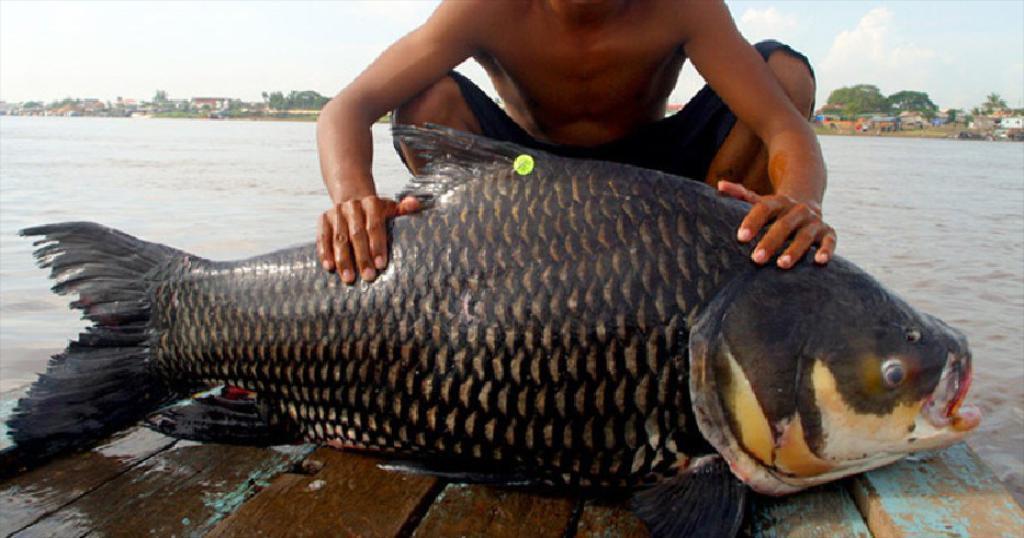What is located on the platform in the image? There is a fish on a platform in the image. Can you describe the person in the image? There is a person in the image, but their specific appearance or actions are not mentioned in the facts. What can be seen in the background of the image? There is water, houses, trees, and the sky visible in the background of the image. What type of seed is being planted by the person in the image? There is no mention of planting or seeds in the image; it features a fish on a platform and a person, but no planting activity. 